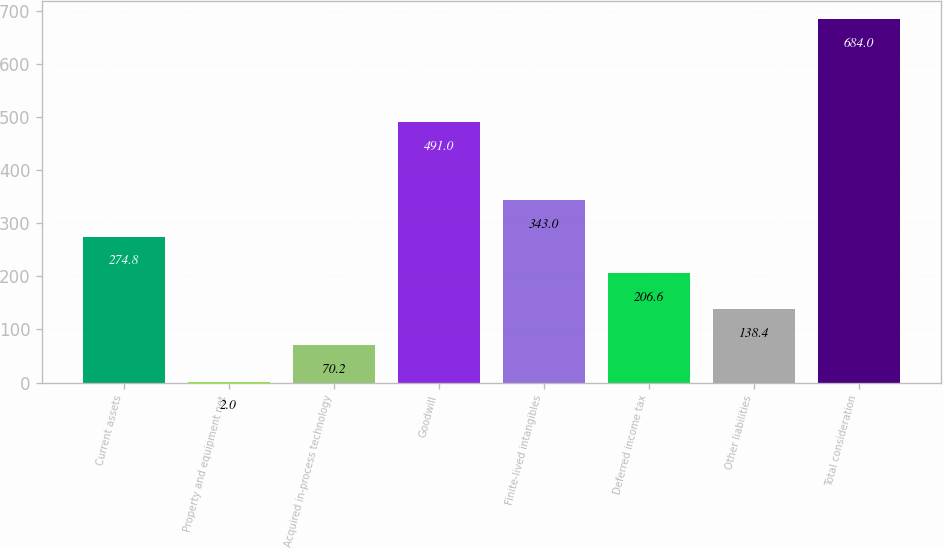Convert chart. <chart><loc_0><loc_0><loc_500><loc_500><bar_chart><fcel>Current assets<fcel>Property and equipment net<fcel>Acquired in-process technology<fcel>Goodwill<fcel>Finite-lived intangibles<fcel>Deferred income tax<fcel>Other liabilities<fcel>Total consideration<nl><fcel>274.8<fcel>2<fcel>70.2<fcel>491<fcel>343<fcel>206.6<fcel>138.4<fcel>684<nl></chart> 